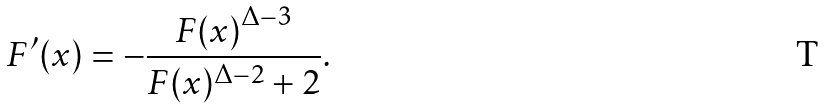Convert formula to latex. <formula><loc_0><loc_0><loc_500><loc_500>F ^ { \prime } ( x ) = - \frac { { F ( x ) } ^ { \Delta - 3 } } { F ( x ) ^ { \Delta - 2 } + 2 } .</formula> 